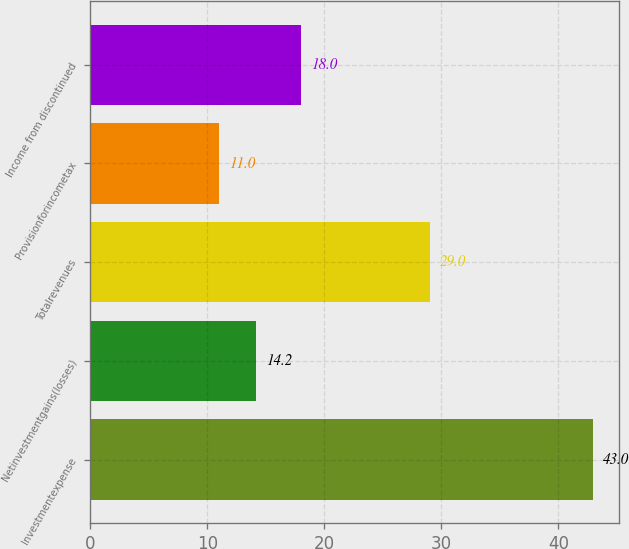Convert chart. <chart><loc_0><loc_0><loc_500><loc_500><bar_chart><fcel>Investmentexpense<fcel>Netinvestmentgains(losses)<fcel>Totalrevenues<fcel>Provisionforincometax<fcel>Income from discontinued<nl><fcel>43<fcel>14.2<fcel>29<fcel>11<fcel>18<nl></chart> 